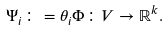Convert formula to latex. <formula><loc_0><loc_0><loc_500><loc_500>\Psi _ { i } \colon = \theta _ { i } \Phi \colon V \rightarrow \mathbb { R } ^ { k } .</formula> 